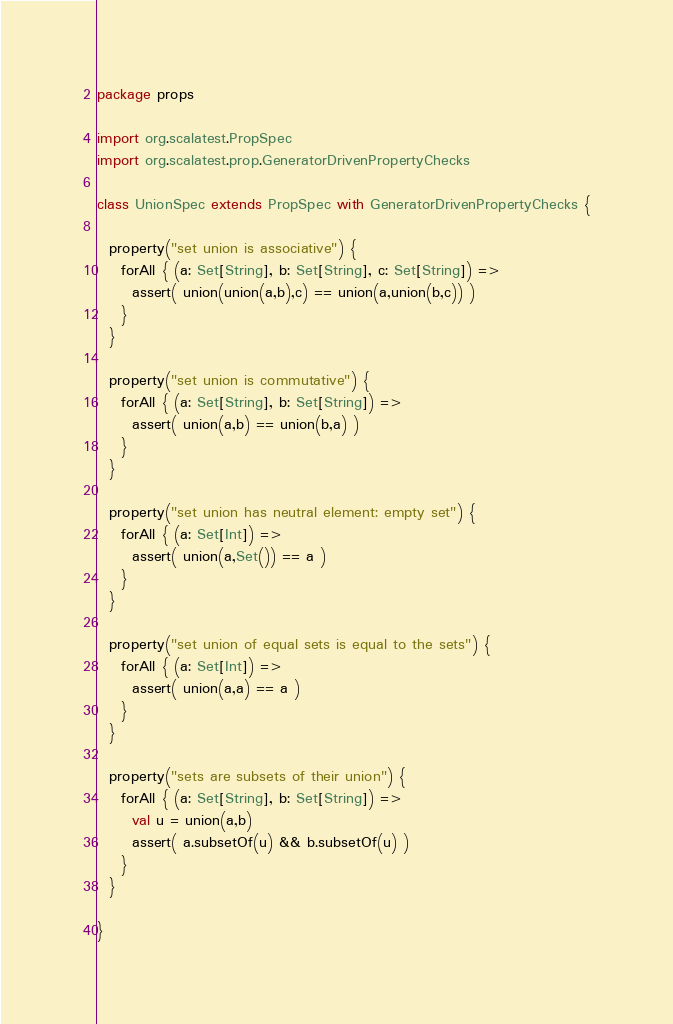Convert code to text. <code><loc_0><loc_0><loc_500><loc_500><_Scala_>package props

import org.scalatest.PropSpec
import org.scalatest.prop.GeneratorDrivenPropertyChecks

class UnionSpec extends PropSpec with GeneratorDrivenPropertyChecks {

  property("set union is associative") {
    forAll { (a: Set[String], b: Set[String], c: Set[String]) =>
      assert( union(union(a,b),c) == union(a,union(b,c)) )
    }
  }

  property("set union is commutative") {
    forAll { (a: Set[String], b: Set[String]) =>
      assert( union(a,b) == union(b,a) )
    }
  }

  property("set union has neutral element: empty set") {
    forAll { (a: Set[Int]) =>
      assert( union(a,Set()) == a )
    }
  }

  property("set union of equal sets is equal to the sets") {
    forAll { (a: Set[Int]) =>
      assert( union(a,a) == a )
    }
  }

  property("sets are subsets of their union") {
    forAll { (a: Set[String], b: Set[String]) =>
      val u = union(a,b)
      assert( a.subsetOf(u) && b.subsetOf(u) )
    }
  }

}
</code> 